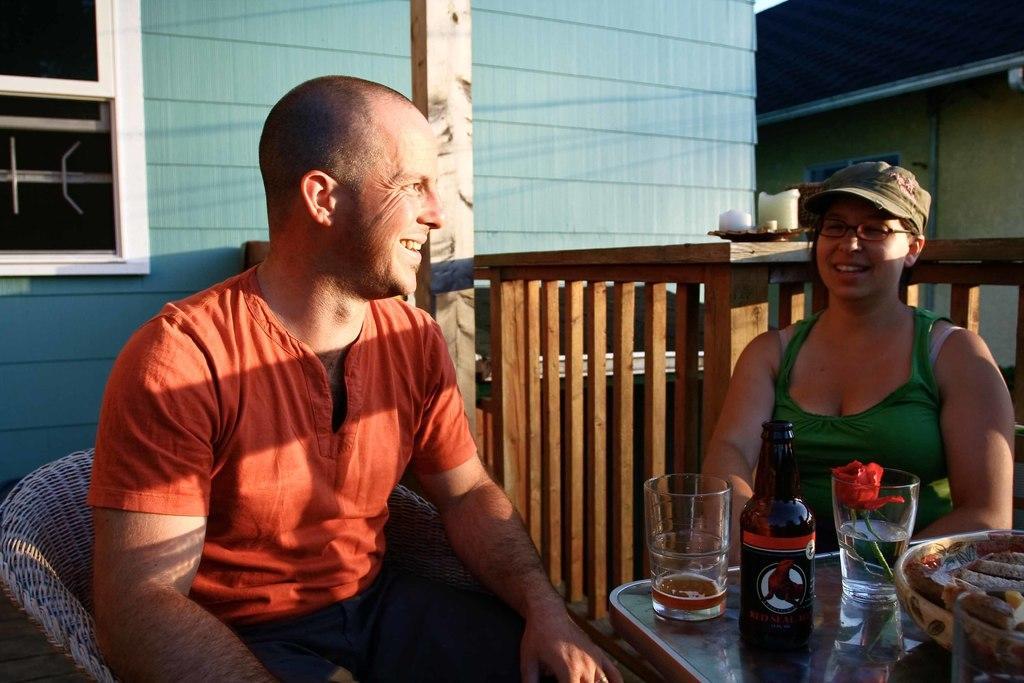Can you describe this image briefly? In this picture we can see man and woman sitting on chairs and smiling and in front of them there is table and on table we can see glass, bottle, flower in glass, basket and in background we can see wall, pillar, window. 